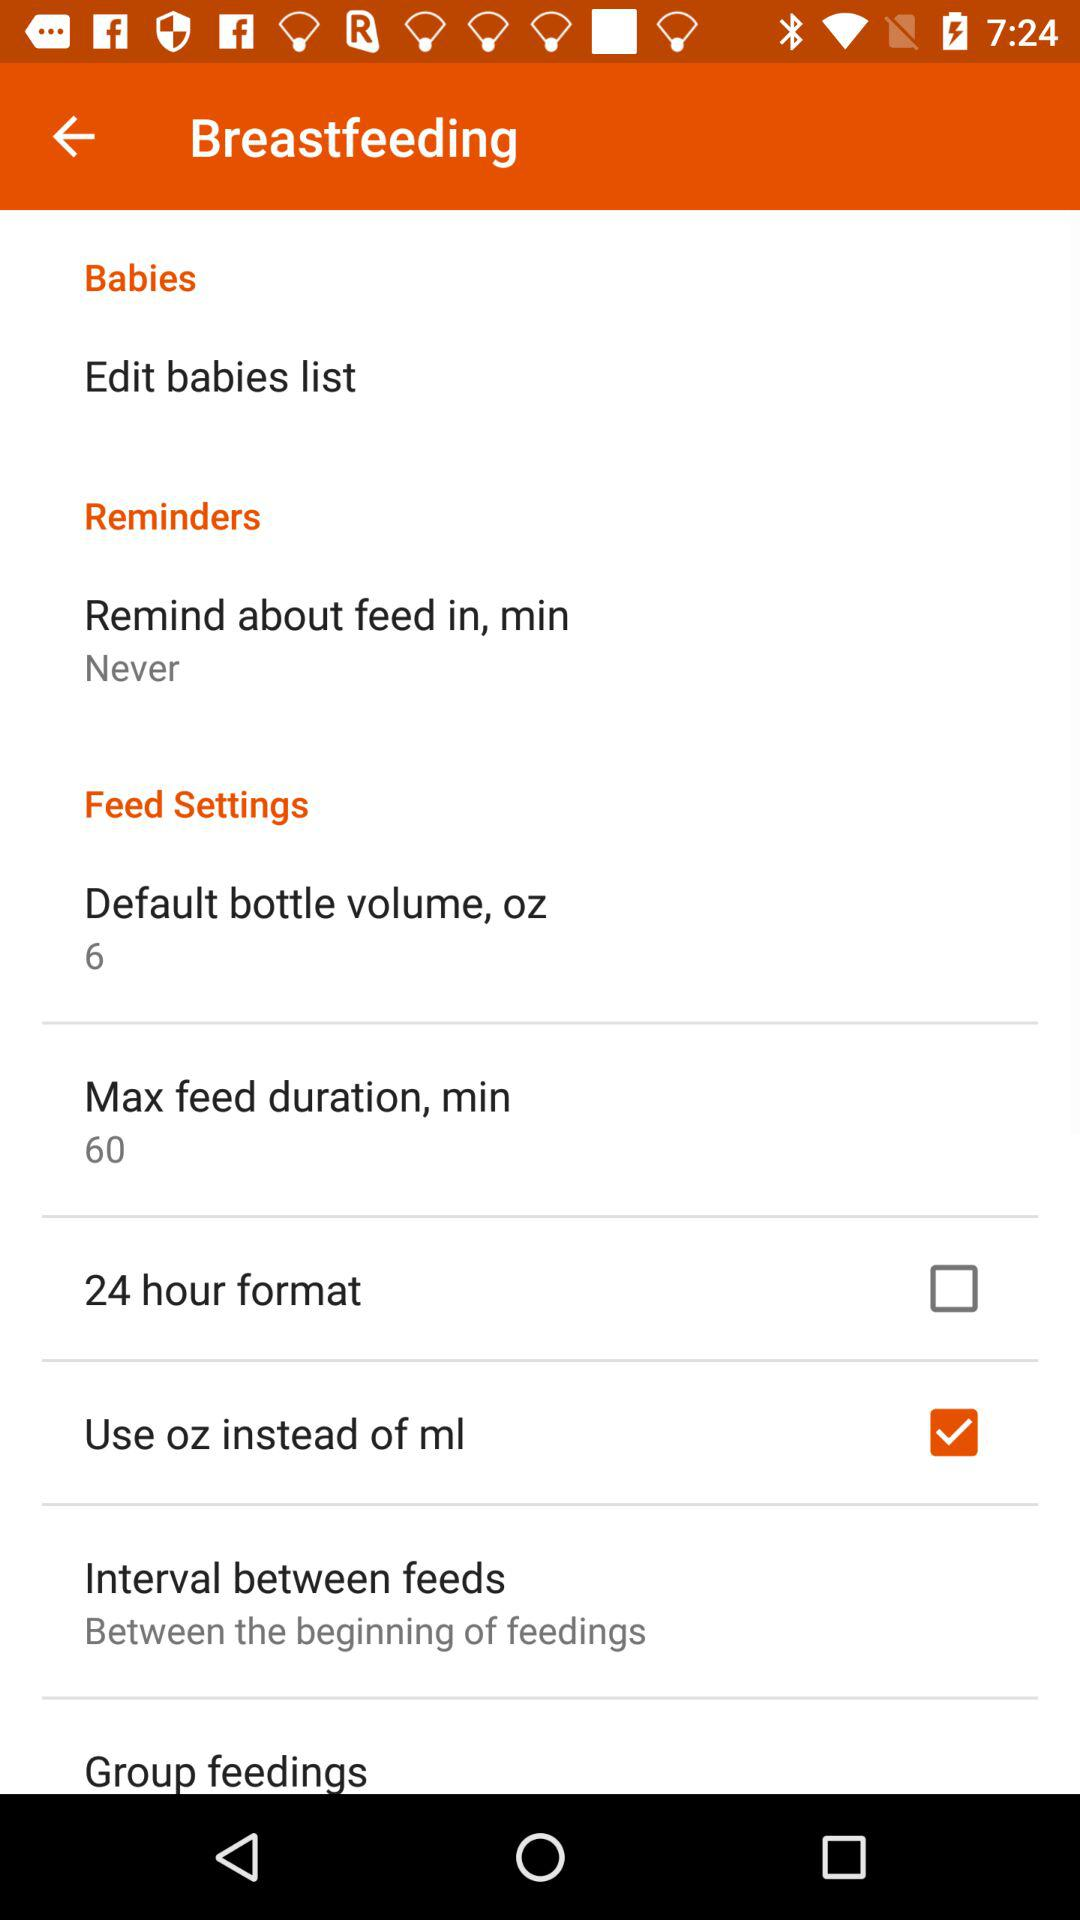What is the default bottle volume in ounces? The default bottle volume in ounces is 6. 